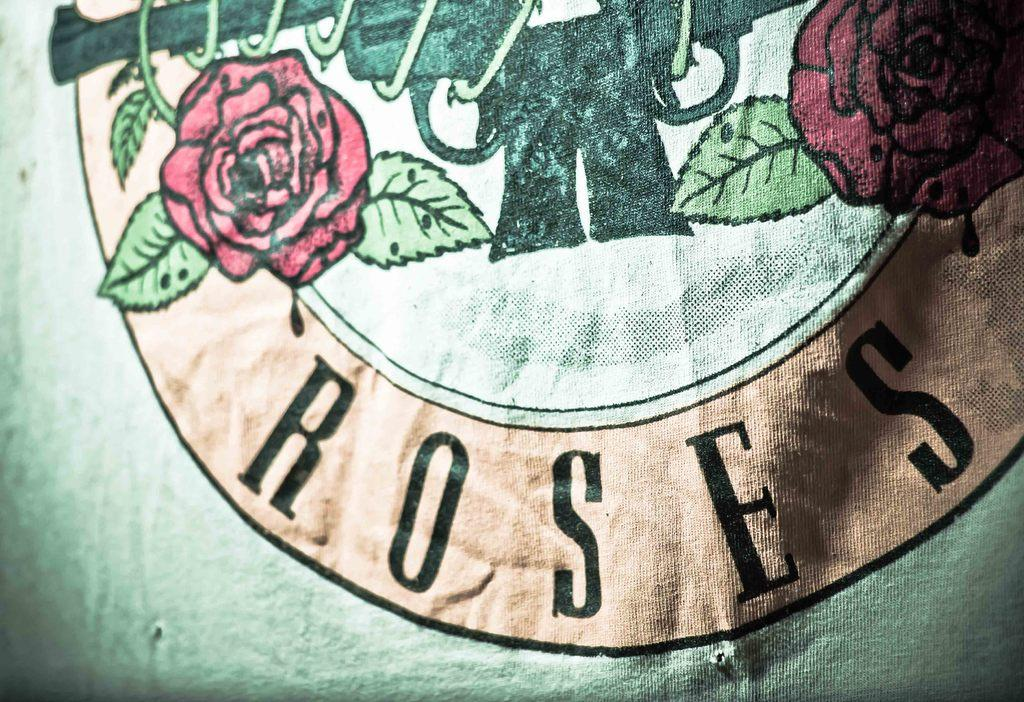What can be seen on the cloth in the image? There are images on the cloth in the image. What else is visible in the image besides the cloth? There is text visible in the image. What type of magic is being performed with the record in the image? There is no record or magic present in the image; it only features text and images on a cloth. What kind of blade is being used to cut the cloth in the image? There is no blade or cutting action depicted in the image; it only shows text and images on a cloth. 